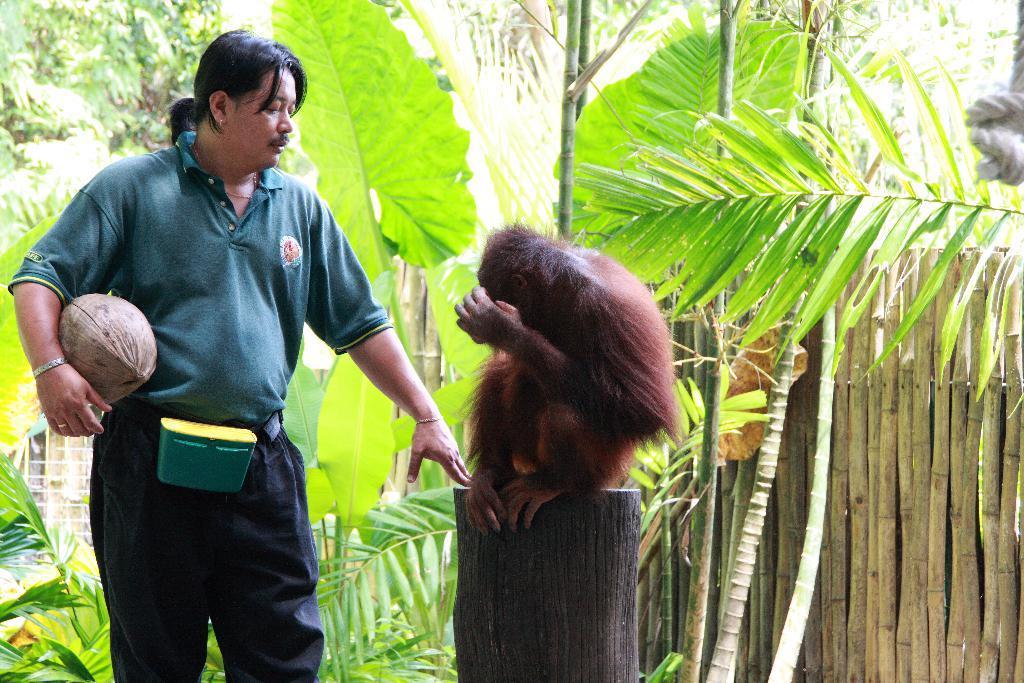How would you summarize this image in a sentence or two? On the background we can see trees. Here we can see a monkey sitting on a branch. Beside to it we can see a man standing and he is holding something in his hand. 